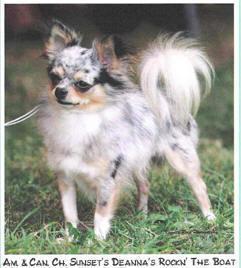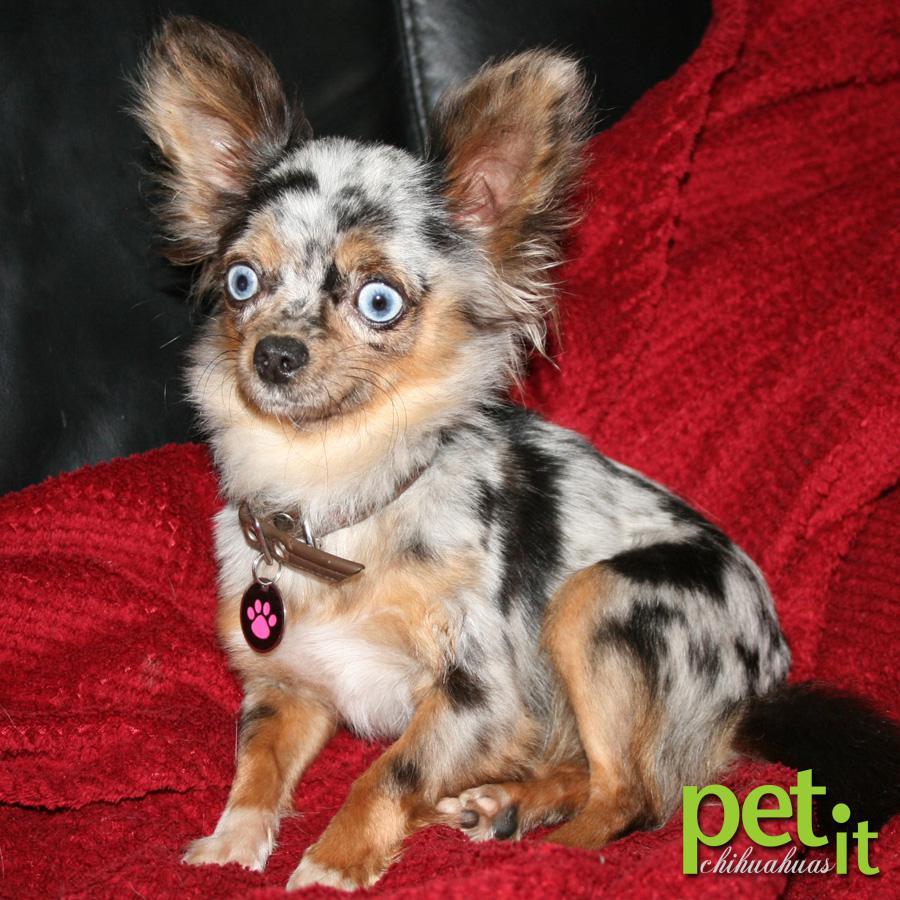The first image is the image on the left, the second image is the image on the right. Assess this claim about the two images: "Exactly two little dogs are shown, one wearing a collar.". Correct or not? Answer yes or no. Yes. The first image is the image on the left, the second image is the image on the right. For the images shown, is this caption "there are at least five animals in one of the images" true? Answer yes or no. No. The first image is the image on the left, the second image is the image on the right. Considering the images on both sides, is "There are two dogs" valid? Answer yes or no. Yes. 